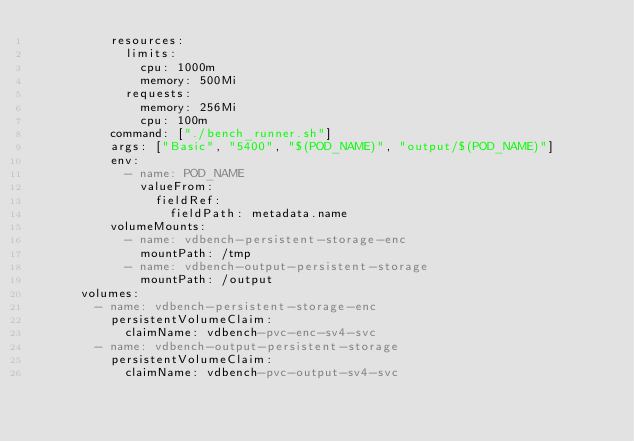<code> <loc_0><loc_0><loc_500><loc_500><_YAML_>          resources:
            limits:
              cpu: 1000m
              memory: 500Mi
            requests:
              memory: 256Mi
              cpu: 100m
          command: ["./bench_runner.sh"]
          args: ["Basic", "5400", "$(POD_NAME)", "output/$(POD_NAME)"]
          env:
            - name: POD_NAME
              valueFrom:
                fieldRef:
                  fieldPath: metadata.name
          volumeMounts:
            - name: vdbench-persistent-storage-enc
              mountPath: /tmp
            - name: vdbench-output-persistent-storage
              mountPath: /output
      volumes:
        - name: vdbench-persistent-storage-enc
          persistentVolumeClaim:
            claimName: vdbench-pvc-enc-sv4-svc
        - name: vdbench-output-persistent-storage
          persistentVolumeClaim:
            claimName: vdbench-pvc-output-sv4-svc
</code> 